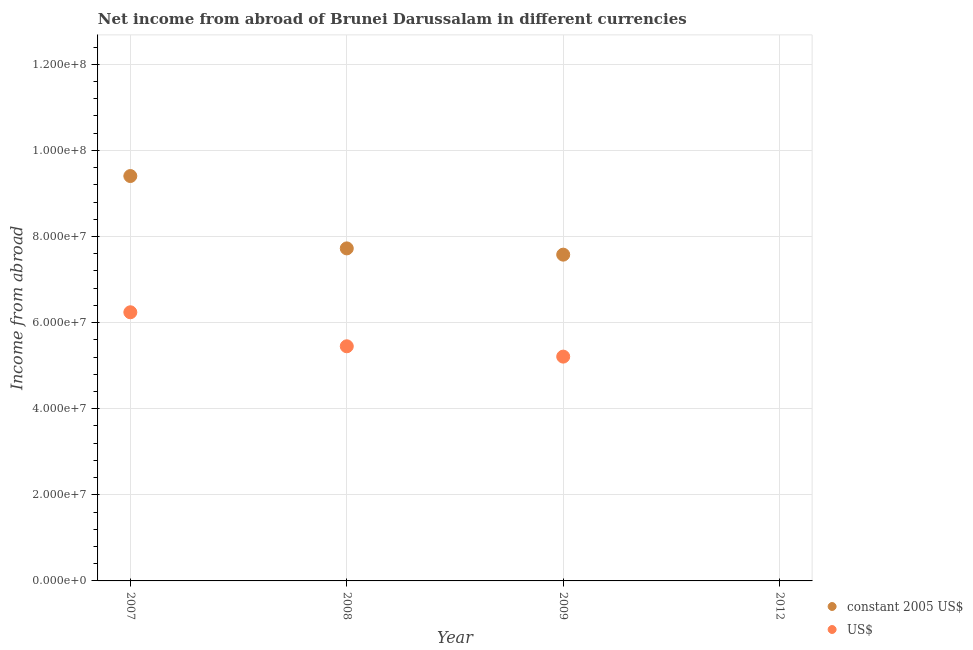What is the income from abroad in us$ in 2009?
Your response must be concise. 5.21e+07. Across all years, what is the maximum income from abroad in constant 2005 us$?
Your answer should be compact. 9.40e+07. In which year was the income from abroad in us$ maximum?
Your answer should be compact. 2007. What is the total income from abroad in us$ in the graph?
Make the answer very short. 1.69e+08. What is the difference between the income from abroad in constant 2005 us$ in 2008 and that in 2009?
Your response must be concise. 1.45e+06. What is the difference between the income from abroad in us$ in 2007 and the income from abroad in constant 2005 us$ in 2008?
Make the answer very short. -1.48e+07. What is the average income from abroad in us$ per year?
Your answer should be compact. 4.23e+07. In the year 2009, what is the difference between the income from abroad in constant 2005 us$ and income from abroad in us$?
Your answer should be very brief. 2.37e+07. What is the ratio of the income from abroad in constant 2005 us$ in 2008 to that in 2009?
Ensure brevity in your answer.  1.02. Is the difference between the income from abroad in us$ in 2007 and 2008 greater than the difference between the income from abroad in constant 2005 us$ in 2007 and 2008?
Provide a succinct answer. No. What is the difference between the highest and the second highest income from abroad in us$?
Offer a terse response. 7.90e+06. What is the difference between the highest and the lowest income from abroad in us$?
Offer a terse response. 6.24e+07. Is the income from abroad in constant 2005 us$ strictly less than the income from abroad in us$ over the years?
Provide a short and direct response. No. Are the values on the major ticks of Y-axis written in scientific E-notation?
Give a very brief answer. Yes. Does the graph contain any zero values?
Make the answer very short. Yes. What is the title of the graph?
Provide a succinct answer. Net income from abroad of Brunei Darussalam in different currencies. Does "Highest 10% of population" appear as one of the legend labels in the graph?
Your answer should be compact. No. What is the label or title of the X-axis?
Provide a short and direct response. Year. What is the label or title of the Y-axis?
Your answer should be very brief. Income from abroad. What is the Income from abroad of constant 2005 US$ in 2007?
Provide a short and direct response. 9.40e+07. What is the Income from abroad in US$ in 2007?
Provide a succinct answer. 6.24e+07. What is the Income from abroad of constant 2005 US$ in 2008?
Give a very brief answer. 7.72e+07. What is the Income from abroad in US$ in 2008?
Make the answer very short. 5.45e+07. What is the Income from abroad of constant 2005 US$ in 2009?
Give a very brief answer. 7.58e+07. What is the Income from abroad in US$ in 2009?
Make the answer very short. 5.21e+07. What is the Income from abroad of constant 2005 US$ in 2012?
Give a very brief answer. 0. Across all years, what is the maximum Income from abroad of constant 2005 US$?
Provide a short and direct response. 9.40e+07. Across all years, what is the maximum Income from abroad in US$?
Provide a succinct answer. 6.24e+07. Across all years, what is the minimum Income from abroad of constant 2005 US$?
Make the answer very short. 0. Across all years, what is the minimum Income from abroad of US$?
Offer a terse response. 0. What is the total Income from abroad in constant 2005 US$ in the graph?
Provide a short and direct response. 2.47e+08. What is the total Income from abroad in US$ in the graph?
Provide a succinct answer. 1.69e+08. What is the difference between the Income from abroad of constant 2005 US$ in 2007 and that in 2008?
Provide a short and direct response. 1.68e+07. What is the difference between the Income from abroad of US$ in 2007 and that in 2008?
Provide a succinct answer. 7.90e+06. What is the difference between the Income from abroad of constant 2005 US$ in 2007 and that in 2009?
Make the answer very short. 1.83e+07. What is the difference between the Income from abroad of US$ in 2007 and that in 2009?
Provide a short and direct response. 1.03e+07. What is the difference between the Income from abroad in constant 2005 US$ in 2008 and that in 2009?
Offer a terse response. 1.45e+06. What is the difference between the Income from abroad in US$ in 2008 and that in 2009?
Your answer should be very brief. 2.40e+06. What is the difference between the Income from abroad of constant 2005 US$ in 2007 and the Income from abroad of US$ in 2008?
Give a very brief answer. 3.95e+07. What is the difference between the Income from abroad of constant 2005 US$ in 2007 and the Income from abroad of US$ in 2009?
Your response must be concise. 4.19e+07. What is the difference between the Income from abroad in constant 2005 US$ in 2008 and the Income from abroad in US$ in 2009?
Make the answer very short. 2.51e+07. What is the average Income from abroad in constant 2005 US$ per year?
Ensure brevity in your answer.  6.18e+07. What is the average Income from abroad in US$ per year?
Offer a terse response. 4.23e+07. In the year 2007, what is the difference between the Income from abroad in constant 2005 US$ and Income from abroad in US$?
Provide a succinct answer. 3.16e+07. In the year 2008, what is the difference between the Income from abroad of constant 2005 US$ and Income from abroad of US$?
Offer a very short reply. 2.27e+07. In the year 2009, what is the difference between the Income from abroad of constant 2005 US$ and Income from abroad of US$?
Ensure brevity in your answer.  2.37e+07. What is the ratio of the Income from abroad in constant 2005 US$ in 2007 to that in 2008?
Offer a very short reply. 1.22. What is the ratio of the Income from abroad in US$ in 2007 to that in 2008?
Offer a very short reply. 1.15. What is the ratio of the Income from abroad in constant 2005 US$ in 2007 to that in 2009?
Offer a terse response. 1.24. What is the ratio of the Income from abroad of US$ in 2007 to that in 2009?
Make the answer very short. 1.2. What is the ratio of the Income from abroad in constant 2005 US$ in 2008 to that in 2009?
Your response must be concise. 1.02. What is the ratio of the Income from abroad in US$ in 2008 to that in 2009?
Your response must be concise. 1.05. What is the difference between the highest and the second highest Income from abroad of constant 2005 US$?
Provide a short and direct response. 1.68e+07. What is the difference between the highest and the second highest Income from abroad in US$?
Provide a succinct answer. 7.90e+06. What is the difference between the highest and the lowest Income from abroad of constant 2005 US$?
Provide a short and direct response. 9.40e+07. What is the difference between the highest and the lowest Income from abroad of US$?
Your answer should be very brief. 6.24e+07. 